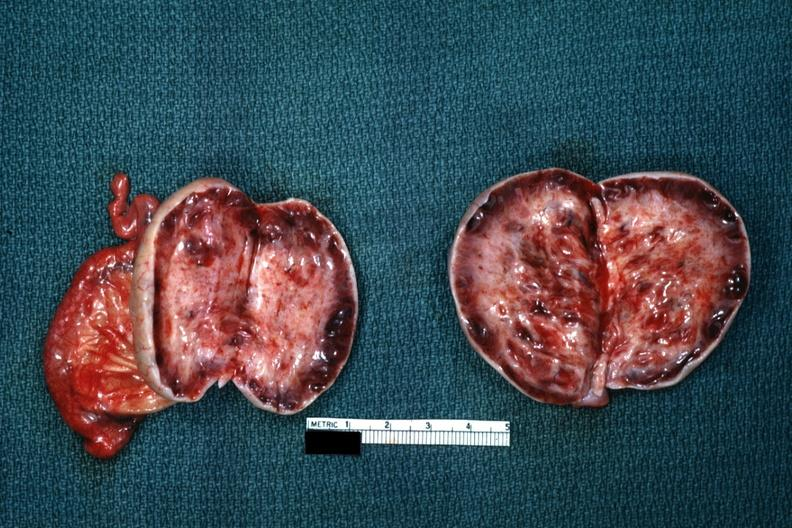what does this image show?
Answer the question using a single word or phrase. Thick capsule with some cysts 